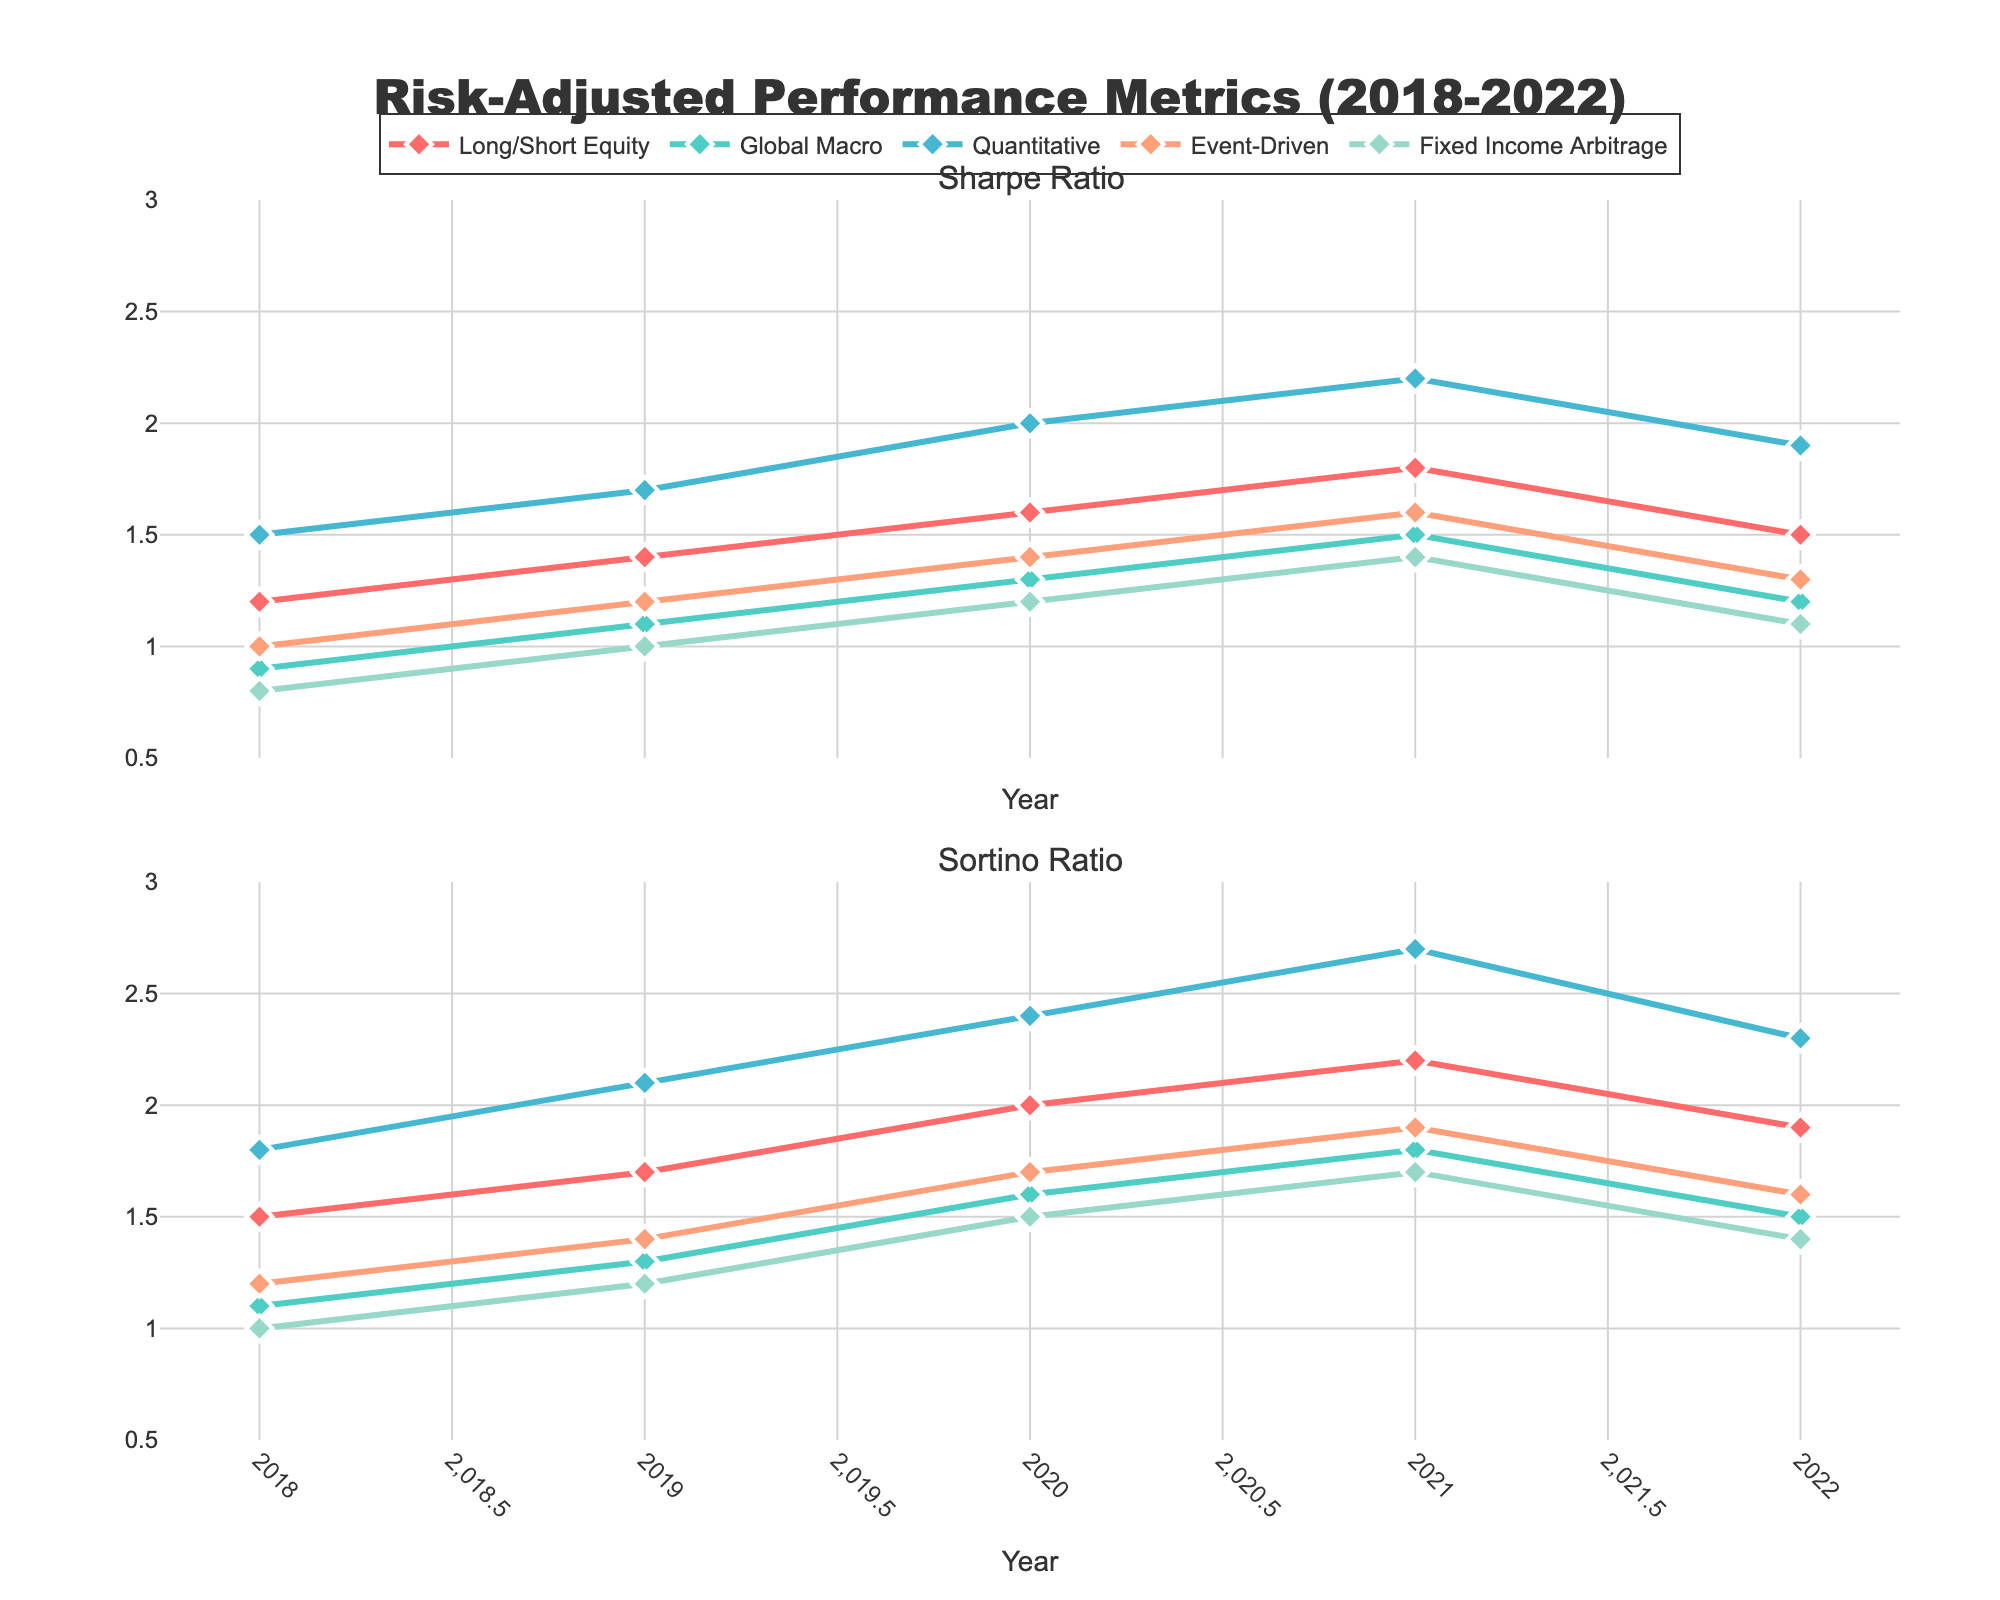Which strategy has the highest Sharpe Ratio in 2020? The Sharpe Ratio for each strategy in 2020 can be seen in the top subplot. Quantitative strategy has the highest Sharpe Ratio in 2020.
Answer: Quantitative Between Long/Short Equity and Global Macro, which strategy had a greater improvement in Sortino Ratio from 2018 to 2020? Calculate the difference in Sortino Ratio for each strategy between 2018 and 2020. Long/Short Equity went from 1.5 to 2.0 (difference = 0.5) and Global Macro went from 1.1 to 1.6 (difference = 0.5). Both strategies had the same improvement.
Answer: Equal What is the average Sharpe Ratio for Fixed Income Arbitrage over the 5-year period? Calculate the average by summing the Sharpe Ratio values for Fixed Income Arbitrage over the years 2018-2022 and dividing by 5: (0.8 + 1.0 + 1.2 + 1.4 + 1.1) / 5 = 5.5 / 5 = 1.1
Answer: 1.1 Which strategy showed the greatest decline in Sharpe Ratio from 2021 to 2022? Look at the Sharpe Ratio in 2021 and 2022 for each strategy. Quantitative declined from 2.2 to 1.9 (decline = -0.3), Long/Short Equity from 1.8 to 1.5 (decline = -0.3), and Fixed Income Arbitrage from 1.4 to 1.1 (decline = -0.3). Quantitative and Long/Short Equity experienced the greatest decline.
Answer: Quantitative and Long/Short Equity Compare the Sortino Ratio of Event-Driven and Global Macro strategies in 2022. Check the Sortino Ratios in 2022 for both strategies in the bottom subplot. Event-Driven has a Sortino Ratio of 1.6, and Global Macro has a Sortino Ratio of 1.5.
Answer: Event-Driven has a higher Sortino Ratio What trend can be observed in the Sharpe Ratio for the Long/Short Equity strategy over the 5-year period? Observe the Sharpe Ratio points in the top subplot for the Long/Short Equity strategy from 2018 to 2022. Initially increasing from 2018 to 2021, it declined in 2022.
Answer: Increasing until 2021, then decreasing Identify the strategy with the most consistent Sortino Ratio over the 5 years. Compare the year-to-year Sortino Ratio variations for each strategy. Long/Short Equity has the smallest variations across years.
Answer: Long/Short Equity Which strategy had the highest Sortino Ratio in 2021? Look at the Sortino Ratio for each strategy in 2021 in the bottom subplot. Quantitative had the highest Sortino Ratio in 2021.
Answer: Quantitative 